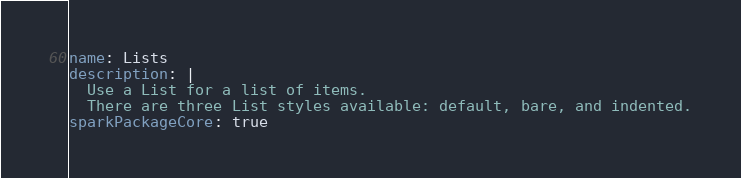<code> <loc_0><loc_0><loc_500><loc_500><_YAML_>name: Lists
description: |
  Use a List for a list of items.
  There are three List styles available: default, bare, and indented.
sparkPackageCore: true
</code> 